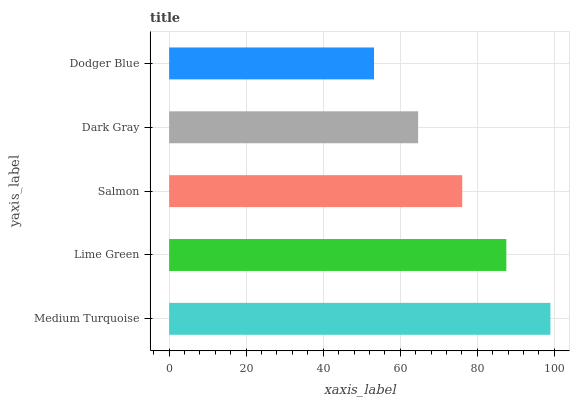Is Dodger Blue the minimum?
Answer yes or no. Yes. Is Medium Turquoise the maximum?
Answer yes or no. Yes. Is Lime Green the minimum?
Answer yes or no. No. Is Lime Green the maximum?
Answer yes or no. No. Is Medium Turquoise greater than Lime Green?
Answer yes or no. Yes. Is Lime Green less than Medium Turquoise?
Answer yes or no. Yes. Is Lime Green greater than Medium Turquoise?
Answer yes or no. No. Is Medium Turquoise less than Lime Green?
Answer yes or no. No. Is Salmon the high median?
Answer yes or no. Yes. Is Salmon the low median?
Answer yes or no. Yes. Is Dodger Blue the high median?
Answer yes or no. No. Is Dodger Blue the low median?
Answer yes or no. No. 